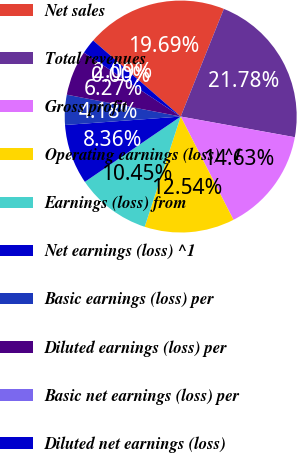<chart> <loc_0><loc_0><loc_500><loc_500><pie_chart><fcel>Net sales<fcel>Total revenues<fcel>Gross profit<fcel>Operating earnings (loss) ^1<fcel>Earnings (loss) from<fcel>Net earnings (loss) ^1<fcel>Basic earnings (loss) per<fcel>Diluted earnings (loss) per<fcel>Basic net earnings (loss) per<fcel>Diluted net earnings (loss)<nl><fcel>19.69%<fcel>21.78%<fcel>14.63%<fcel>12.54%<fcel>10.45%<fcel>8.36%<fcel>4.18%<fcel>6.27%<fcel>0.0%<fcel>2.09%<nl></chart> 